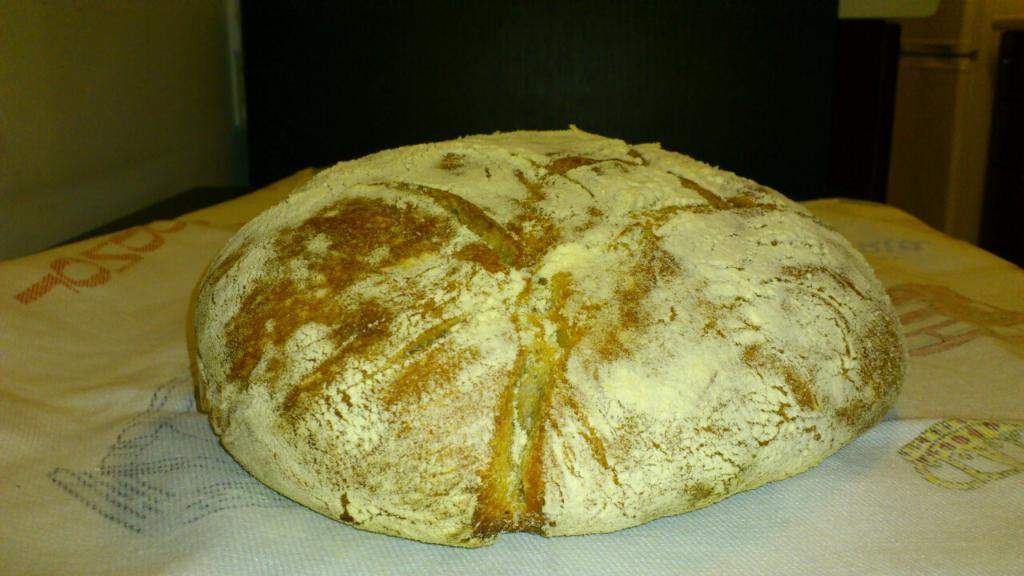What is the main subject of the image? There is a food item on a paper napkin. What can be seen in the background of the image? There is a wall and a closet in the background of the image. How many letters does the laborer carry in the image? There is no laborer or letters present in the image. What type of carriage can be seen in the image? There is no carriage present in the image. 